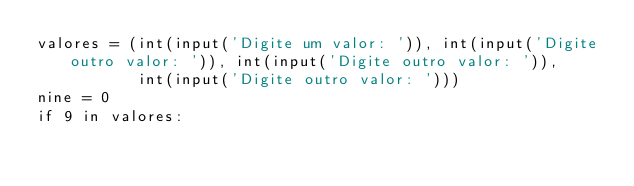Convert code to text. <code><loc_0><loc_0><loc_500><loc_500><_Python_>valores = (int(input('Digite um valor: ')), int(input('Digite outro valor: ')), int(input('Digite outro valor: ')),
           int(input('Digite outro valor: ')))
nine = 0
if 9 in valores:</code> 